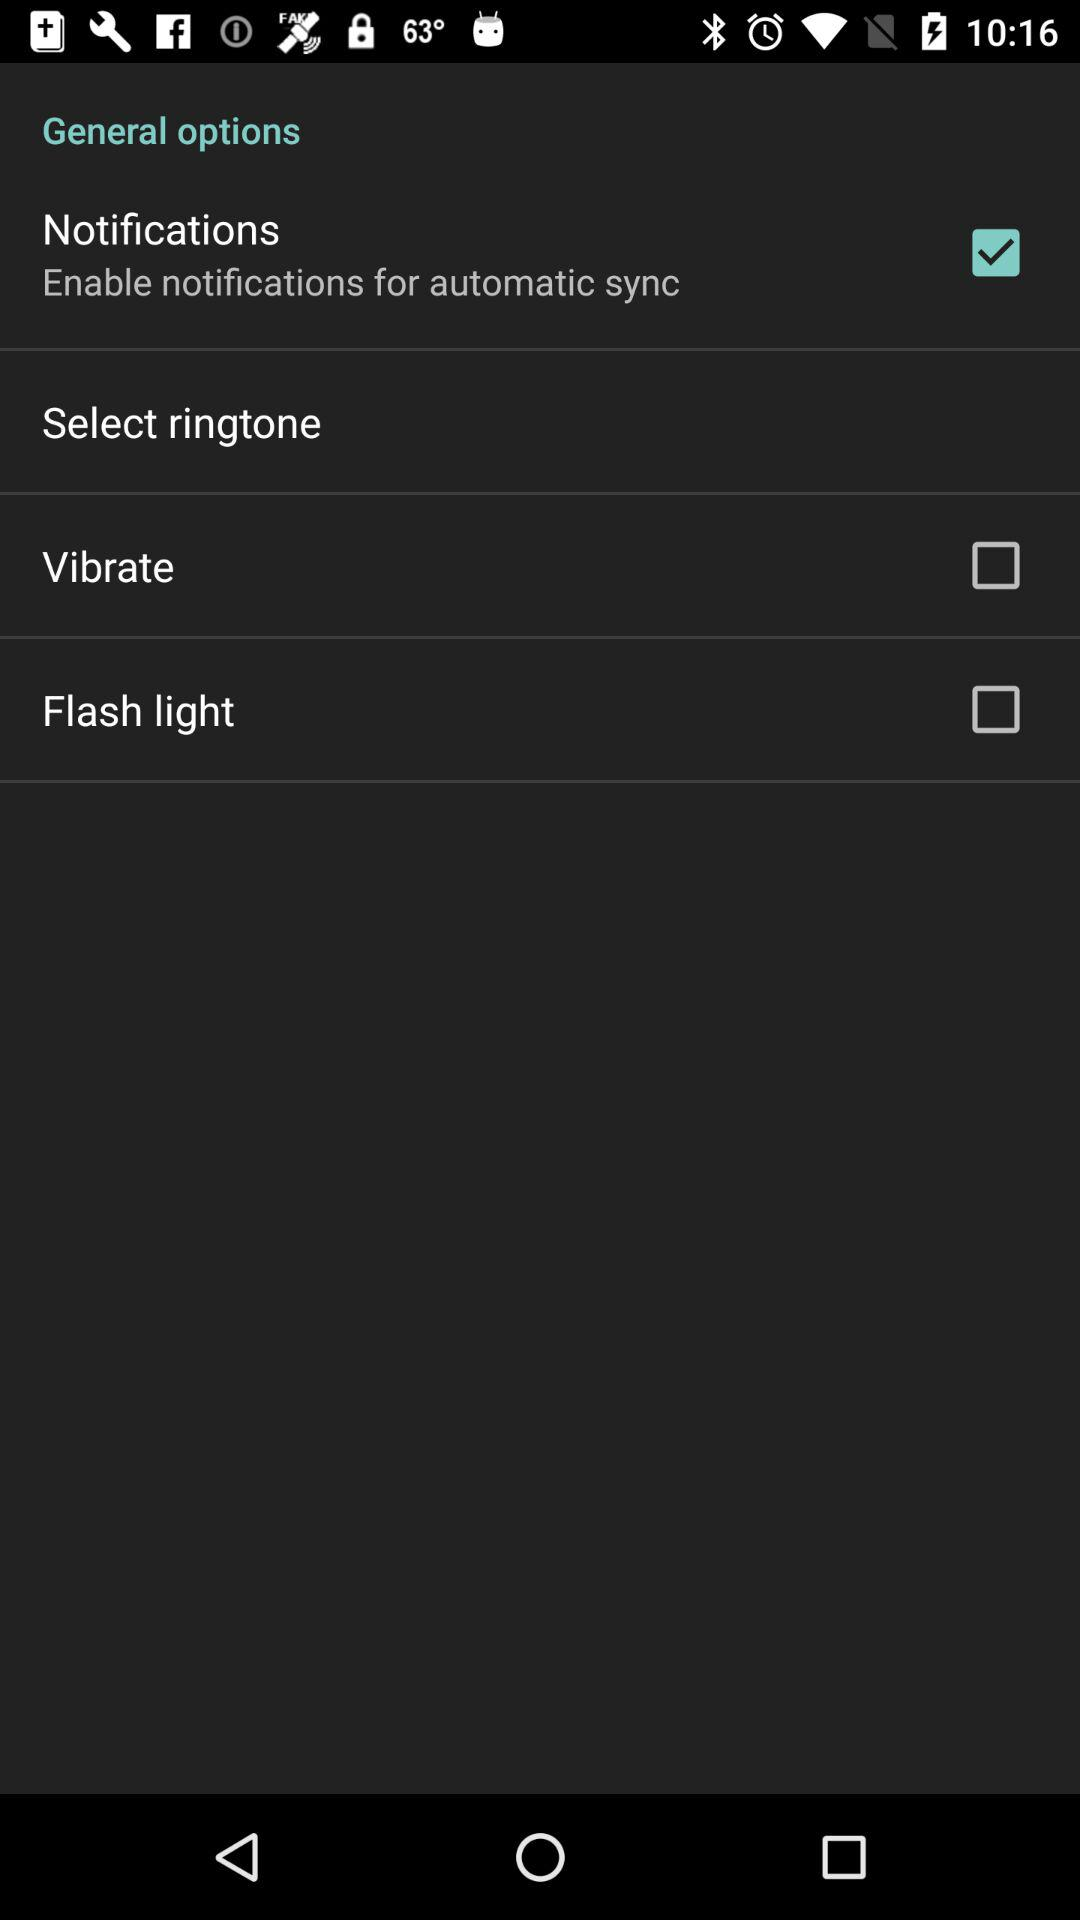What is the status of notifications? The status is "on". 